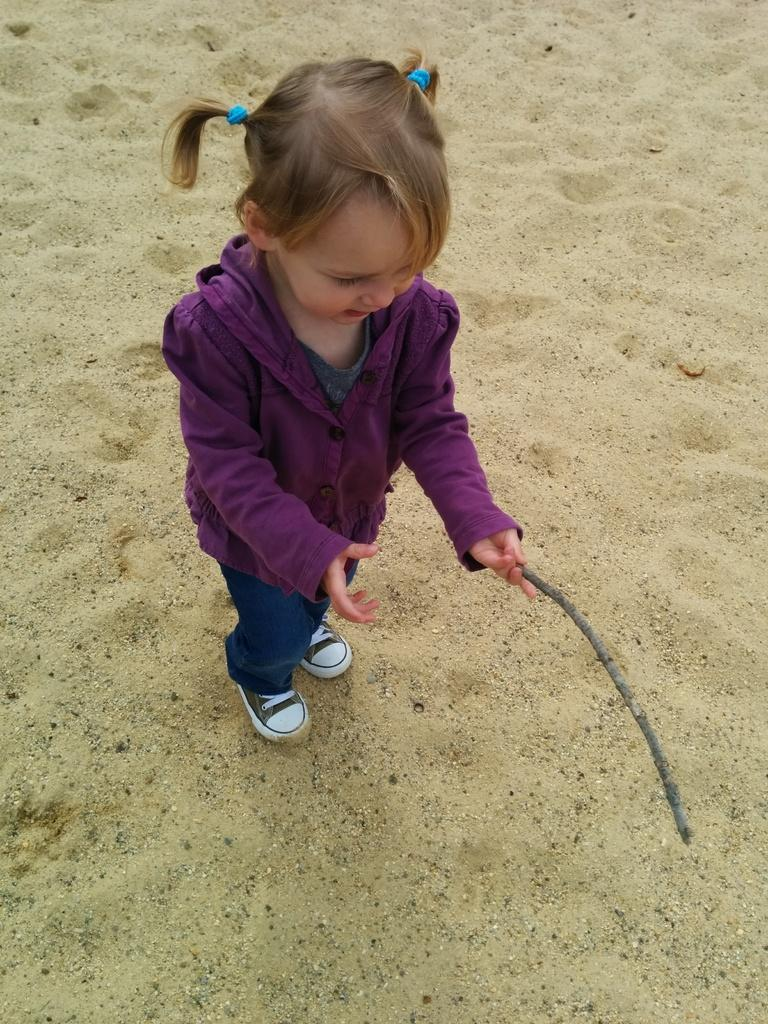What is the main subject of the picture? The main subject of the picture is a kid. What is the kid wearing? The kid is wearing a purple sweater, blue pants, and black shoes. What is the kid holding in her hands? The kid is holding a stick in her hands. What type of surface can be seen in the image? There is sand visible in the image. How many birds are sitting on the chairs in the image? There are no chairs or birds present in the image. 